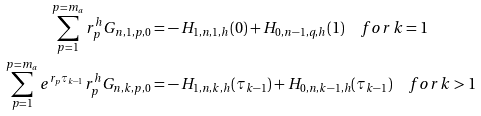Convert formula to latex. <formula><loc_0><loc_0><loc_500><loc_500>\sum _ { p = 1 } ^ { p = m _ { a } } r _ { p } ^ { h } G _ { n , 1 , p , 0 } = & - H _ { 1 , n , 1 , h } ( 0 ) + H _ { 0 , n - 1 , q , h } ( 1 ) \quad f o r \, k = 1 \\ \sum _ { p = 1 } ^ { p = m _ { a } } e ^ { r _ { p } \tau _ { k - 1 } } r _ { p } ^ { h } G _ { n , k , p , 0 } = & - H _ { 1 , n , k , h } ( \tau _ { k - 1 } ) + H _ { 0 , n , k - 1 , h } ( \tau _ { k - 1 } ) \quad f o r \, k > 1</formula> 